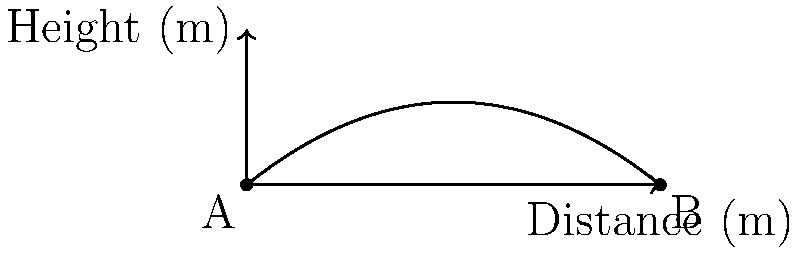In a dramatic twist during the showstopper challenge, a contestant accidentally launches their triple-tiered Victoria sponge cake across the tent. The cake's trajectory follows the parabolic path shown in the graph. If the height of the cake is given by the function $h(x) = -0.1x^2 + 0.8x$, where $x$ is the horizontal distance in meters, what is the maximum height reached by the cake to the nearest tenth of a meter? To find the maximum height of the parabolic trajectory, we need to follow these steps:

1) The function given is $h(x) = -0.1x^2 + 0.8x$, which is in the form of a quadratic equation $ax^2 + bx + c$.

2) For a parabola, the x-coordinate of the vertex (which corresponds to the maximum height for this upward-opening parabola) is given by the formula $x = -\frac{b}{2a}$.

3) In this case, $a = -0.1$ and $b = 0.8$. Let's substitute these values:

   $x = -\frac{0.8}{2(-0.1)} = -\frac{0.8}{-0.2} = 4$ meters

4) To find the maximum height, we need to substitute this x-value back into the original function:

   $h(4) = -0.1(4)^2 + 0.8(4)$
         $= -0.1(16) + 3.2$
         $= -1.6 + 3.2$
         $= 1.6$ meters

5) Rounding to the nearest tenth of a meter, we get 1.6 meters.

This result shows that the cake reaches its maximum height of 1.6 meters when it's 4 meters away from its starting point horizontally.
Answer: 1.6 meters 